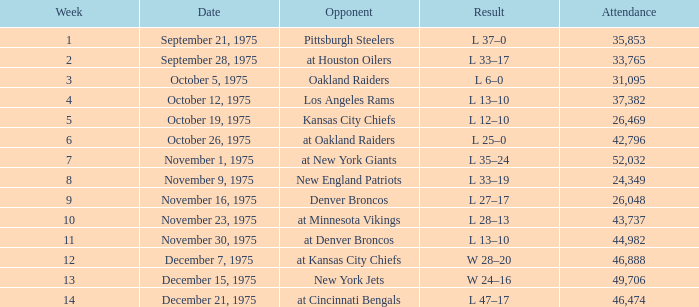What is the lowest Week when the result was l 6–0? 3.0. 